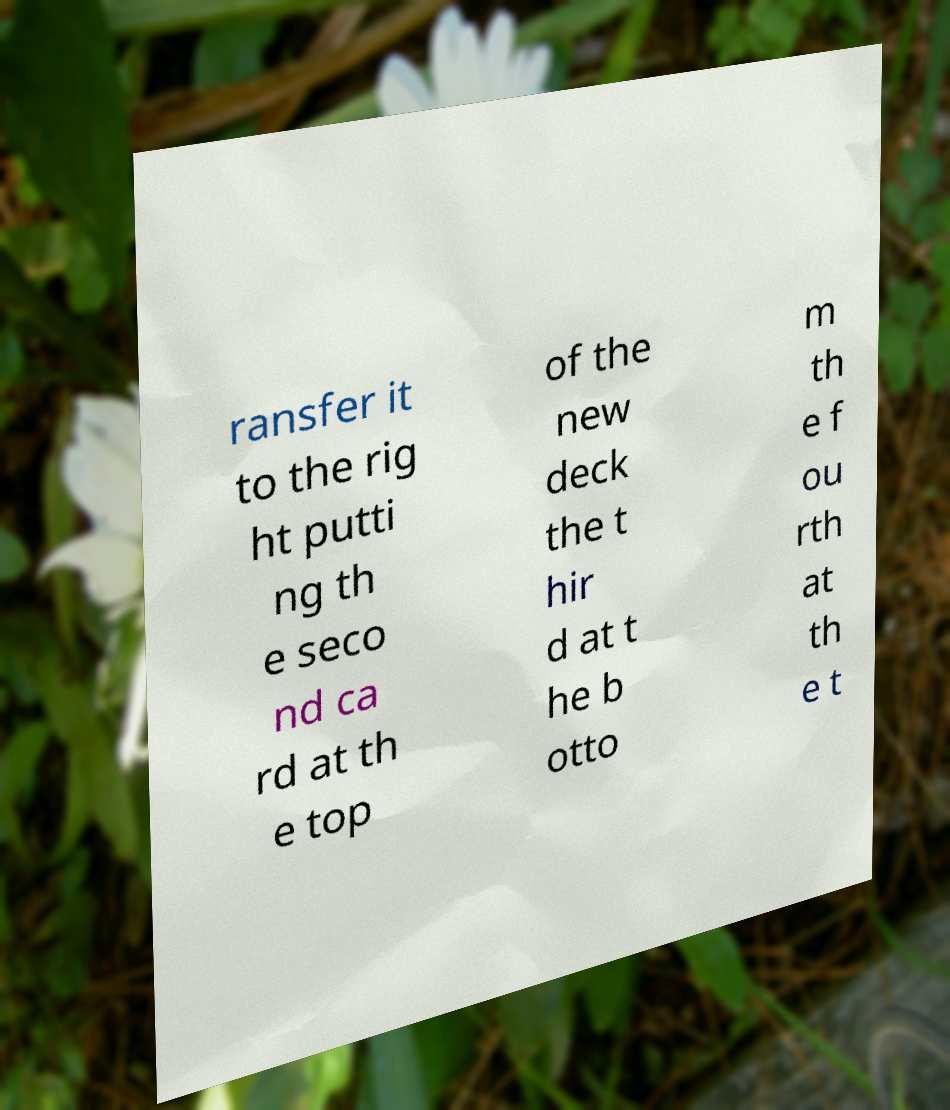There's text embedded in this image that I need extracted. Can you transcribe it verbatim? ransfer it to the rig ht putti ng th e seco nd ca rd at th e top of the new deck the t hir d at t he b otto m th e f ou rth at th e t 